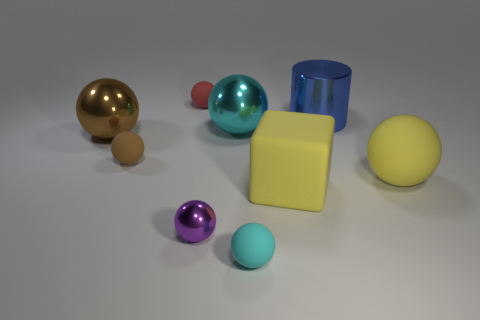Subtract all brown matte balls. How many balls are left? 6 Subtract all purple balls. How many balls are left? 6 Subtract all purple cylinders. How many brown spheres are left? 2 Subtract all balls. How many objects are left? 2 Subtract 1 cylinders. How many cylinders are left? 0 Subtract 0 brown blocks. How many objects are left? 9 Subtract all yellow cylinders. Subtract all yellow spheres. How many cylinders are left? 1 Subtract all big yellow cylinders. Subtract all tiny purple shiny objects. How many objects are left? 8 Add 5 large yellow cubes. How many large yellow cubes are left? 6 Add 2 small brown things. How many small brown things exist? 3 